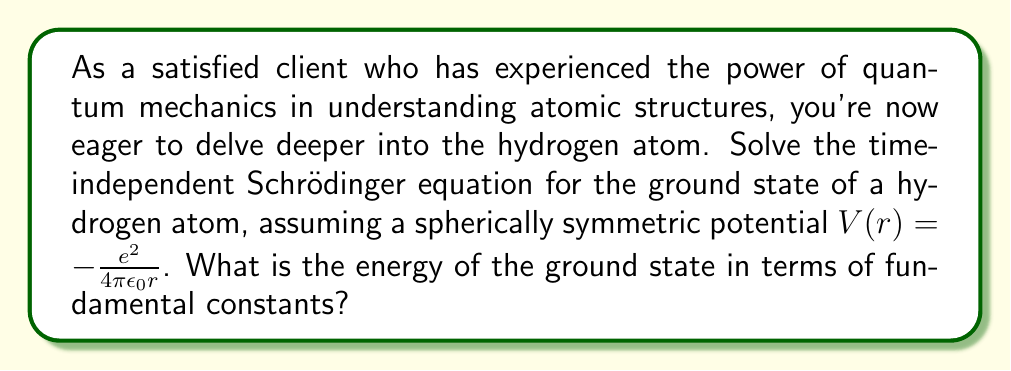Solve this math problem. Let's solve this step-by-step:

1) The time-independent Schrödinger equation is:

   $$-\frac{\hbar^2}{2m}\nabla^2\psi + V(r)\psi = E\psi$$

2) For a spherically symmetric potential, we can separate the wavefunction into radial and angular parts:

   $$\psi(r,\theta,\phi) = R(r)Y_{lm}(\theta,\phi)$$

3) The ground state has $l=0$, $m=0$, so $Y_{00} = \frac{1}{\sqrt{4\pi}}$. We focus on the radial equation:

   $$-\frac{\hbar^2}{2m}\left(\frac{d^2R}{dr^2} + \frac{2}{r}\frac{dR}{dr}\right) - \frac{e^2}{4\pi\epsilon_0r}R = ER$$

4) Let's introduce dimensionless variables:

   $$\rho = \frac{2r}{a_0}, \quad a_0 = \frac{4\pi\epsilon_0\hbar^2}{me^2}$$

   where $a_0$ is the Bohr radius.

5) The equation becomes:

   $$\frac{d^2R}{d\rho^2} + \frac{2}{\rho}\frac{dR}{d\rho} + \left(\frac{E}{E_0} + \frac{2}{\rho}\right)R = 0$$

   where $E_0 = \frac{\hbar^2}{2ma_0^2} = \frac{me^4}{32\pi^2\epsilon_0^2\hbar^2}$

6) For the ground state, we expect an exponential decay: $R(\rho) = Ne^{-\alpha\rho}$

7) Substituting this into the equation:

   $$\alpha^2 - \frac{2\alpha}{\rho} - \frac{2}{\rho} + \frac{E}{E_0} = 0$$

8) For this to be true for all $\rho$, we must have:

   $$\alpha = 1, \quad \frac{E}{E_0} = -1$$

9) Therefore, the energy of the ground state is:

   $$E = -E_0 = -\frac{me^4}{32\pi^2\epsilon_0^2\hbar^2}$$
Answer: $E = -\frac{me^4}{32\pi^2\epsilon_0^2\hbar^2}$ 